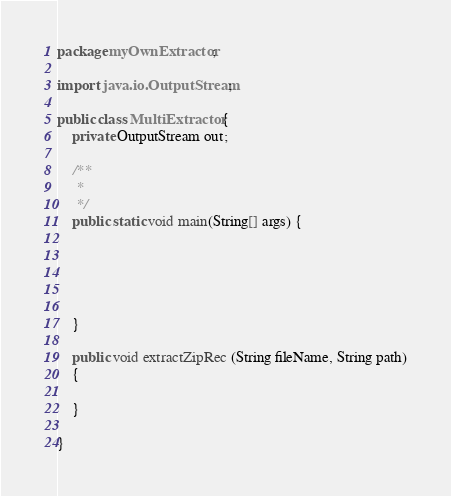<code> <loc_0><loc_0><loc_500><loc_500><_Java_>package myOwnExtractor;

import java.io.OutputStream;

public class MultiExtractor {
	private OutputStream out;
	 
	/**
	 * 
	 */
	public static void main(String[] args) {
		
		
		
		

	}
	
	public void extractZipRec (String fileName, String path)
	{
		
	}

}
</code> 